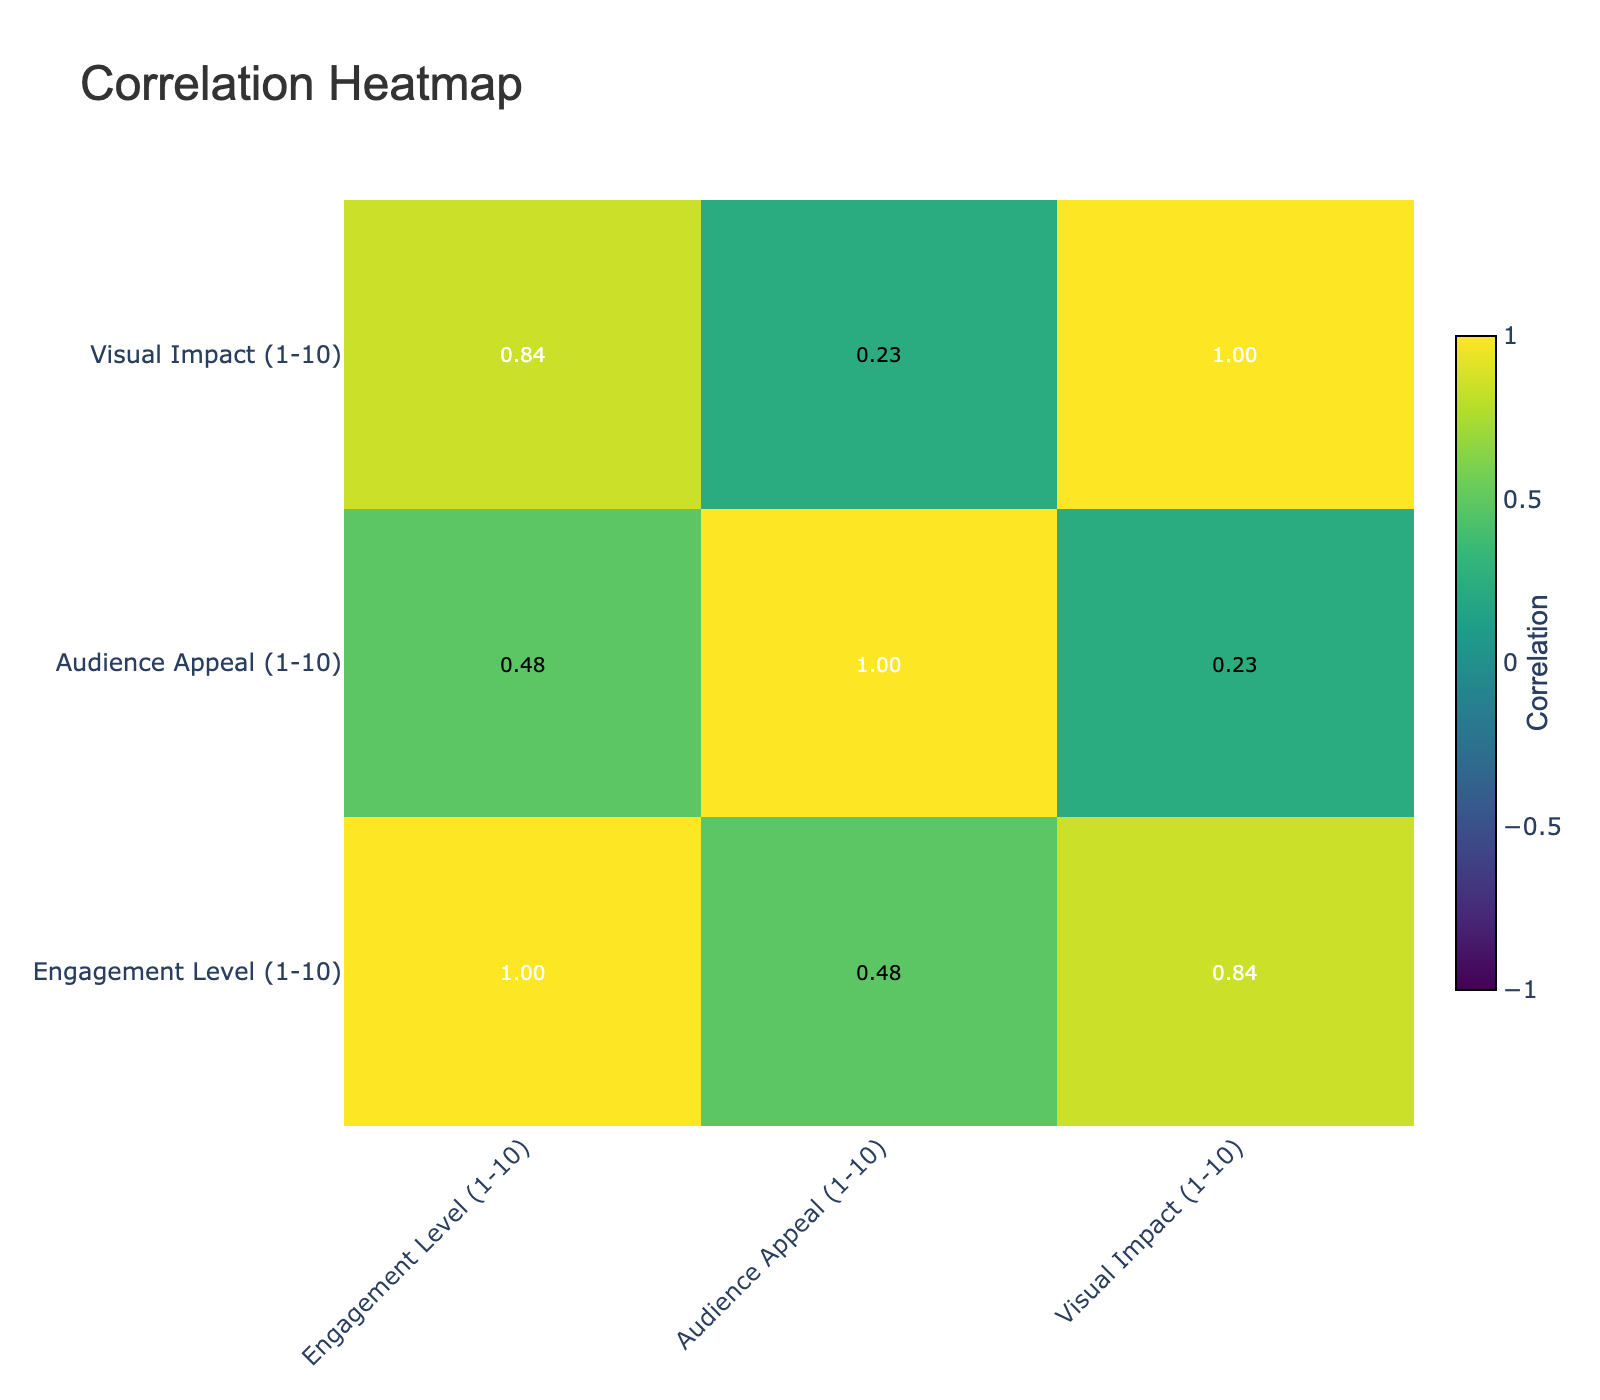What is the engagement level for the Hero character type using a Monochrome palette? The engagement level for the Hero character type with a Monochrome palette is given in the table as 8.
Answer: 8 Which character type has the highest audience appeal? The character type with the highest audience appeal is the Love Interest, with a score of 10.
Answer: Love Interest What is the average visual impact score for both the Antihero and the Wise Elder character types? The visual impact for the Antihero is 10, and for the Wise Elder, it is 7. Calculating the average: (10 + 7) / 2 = 8.5.
Answer: 8.5 Is there a correlation between the Color Palette and the Emotion Evoked? The table does not provide specific correlation values; however, it summarizes various relationships among attributes that suggest diverse emotional responses to different palettes. Therefore, one could say there is a conceptual correlation given the distinct emotions characterized by each palette.
Answer: Yes Which character type has the lowest visual impact, and what is that score? The character type with the lowest visual impact is the Grayscale Antihero, with a score of 5.
Answer: Antihero, 5 What is the difference in engagement levels between the Villain (Complementary Palette) and the Sidekick (Analogous Palette)? The engagement level for the Villain is 9, while the Sidekick has an engagement level of 7. The difference between them: 9 - 7 = 2.
Answer: 2 Does using a Cool Color palette evoke a stronger emotion than a Neon palette for the Antihero? The Cool Color palette evokes Calmness, while the Neon palette evokes Rebellion. Based on common perceptions, these emotions are different, but we cannot deduce a clear "stronger" emotion solely from the table, as it depends on the context.
Answer: No What is the visual impact of the Warm Colors palette for the Love Interest character? The Warm Colors palette for the Love Interest has a visual impact score of 8, which is noted directly in the table.
Answer: 8 How does the Audience Appeal score for the Wise Elder compare to that of the Child Protagonist? The Audience Appeal for the Wise Elder is 8, while for the Child Protagonist, it is 9. Comparing these scores: 8 is less than 9, meaning the Child Protagonist has a higher appeal.
Answer: Child Protagonist has a higher appeal 